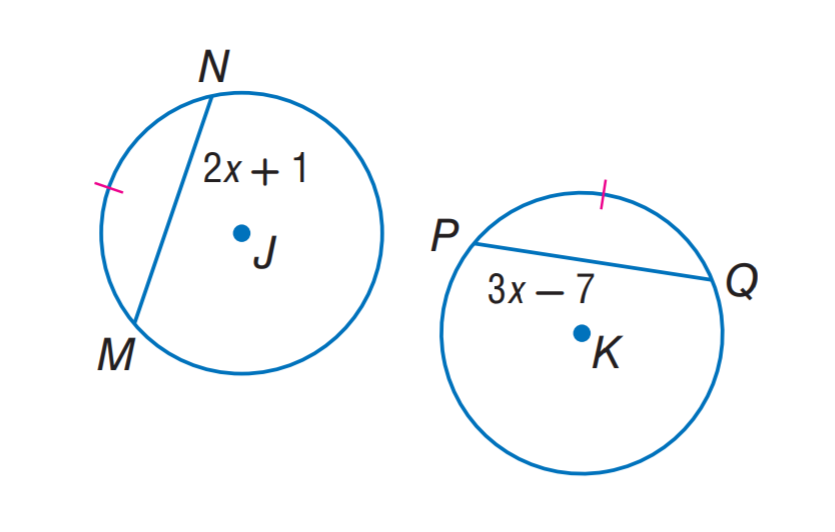Answer the mathemtical geometry problem and directly provide the correct option letter.
Question: \odot J \cong \odot K and \widehat M N \cong \widehat P Q. Find P Q.
Choices: A: 7 B: 17 C: 21 D: 24 B 